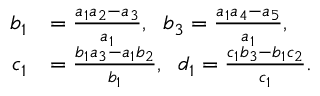<formula> <loc_0><loc_0><loc_500><loc_500>\begin{array} { r l } { b _ { 1 } } & { = \frac { a _ { 1 } a _ { 2 } - a _ { 3 } } { a _ { 1 } } , \, b _ { 3 } = \frac { a _ { 1 } a _ { 4 } - a _ { 5 } } { a _ { 1 } } , } \\ { c _ { 1 } } & { = \frac { b _ { 1 } a _ { 3 } - a _ { 1 } b _ { 2 } } { b _ { 1 } } , \, d _ { 1 } = \frac { c _ { 1 } b _ { 3 } - b _ { 1 } c _ { 2 } } { c _ { 1 } } . } \end{array}</formula> 